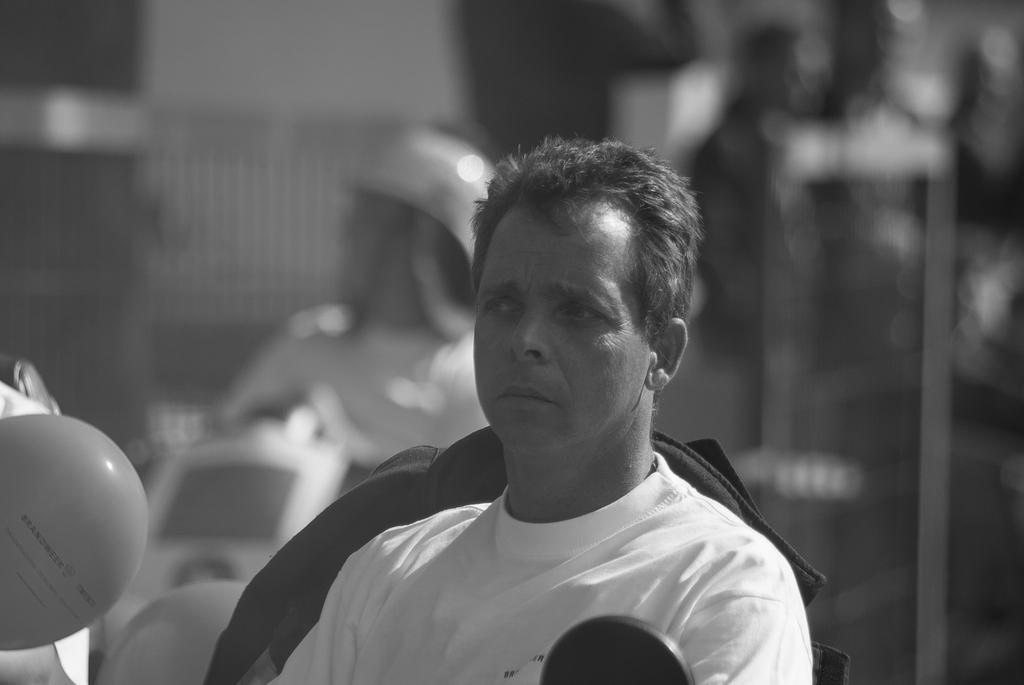What is the main subject of the image? There is a person sitting in the middle of the image. Are there any other people in the image? Yes, there are other people sitting behind the person in the middle. Can you describe the background of the image? The background of the image is blurred. What type of button can be seen on the person's shirt in the image? There is no button visible on the person's shirt in the image. What does the stream taste like in the image? There is no stream present in the image, so it cannot be tasted. 